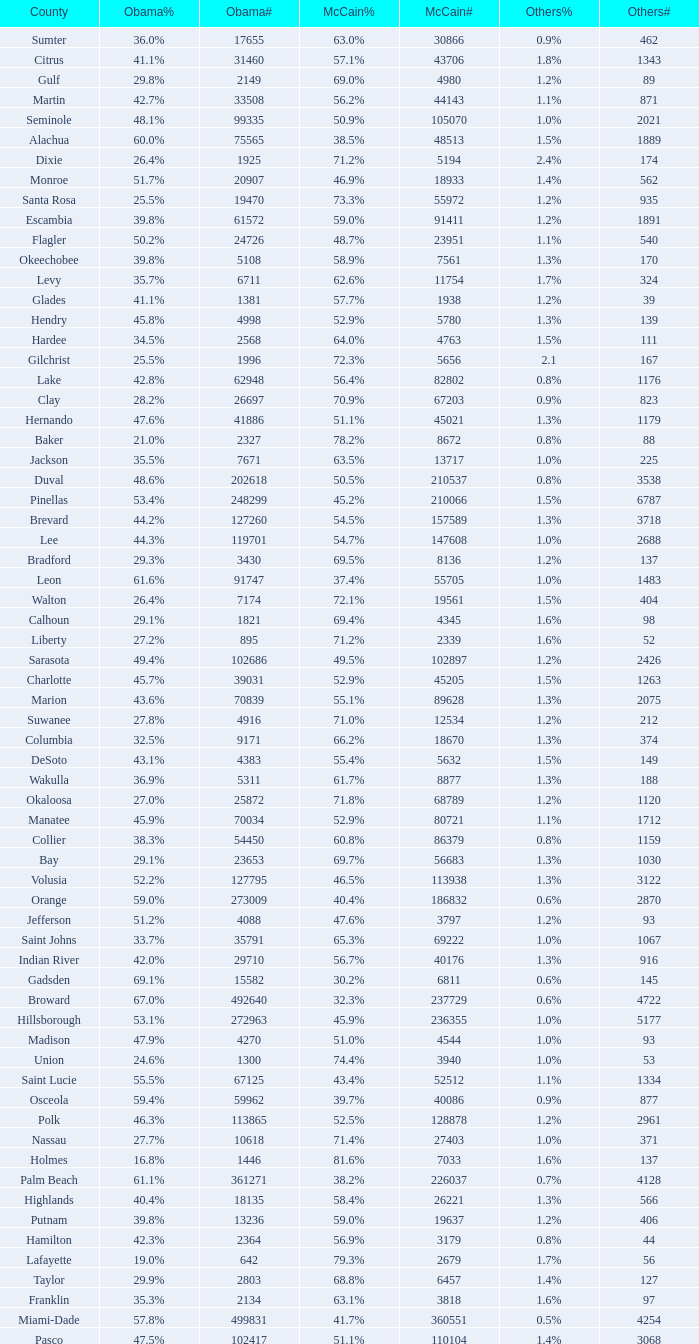What percentage was the others vote when McCain had 52.9% and less than 45205.0 voters? 1.3%. Parse the table in full. {'header': ['County', 'Obama%', 'Obama#', 'McCain%', 'McCain#', 'Others%', 'Others#'], 'rows': [['Sumter', '36.0%', '17655', '63.0%', '30866', '0.9%', '462'], ['Citrus', '41.1%', '31460', '57.1%', '43706', '1.8%', '1343'], ['Gulf', '29.8%', '2149', '69.0%', '4980', '1.2%', '89'], ['Martin', '42.7%', '33508', '56.2%', '44143', '1.1%', '871'], ['Seminole', '48.1%', '99335', '50.9%', '105070', '1.0%', '2021'], ['Alachua', '60.0%', '75565', '38.5%', '48513', '1.5%', '1889'], ['Dixie', '26.4%', '1925', '71.2%', '5194', '2.4%', '174'], ['Monroe', '51.7%', '20907', '46.9%', '18933', '1.4%', '562'], ['Santa Rosa', '25.5%', '19470', '73.3%', '55972', '1.2%', '935'], ['Escambia', '39.8%', '61572', '59.0%', '91411', '1.2%', '1891'], ['Flagler', '50.2%', '24726', '48.7%', '23951', '1.1%', '540'], ['Okeechobee', '39.8%', '5108', '58.9%', '7561', '1.3%', '170'], ['Levy', '35.7%', '6711', '62.6%', '11754', '1.7%', '324'], ['Glades', '41.1%', '1381', '57.7%', '1938', '1.2%', '39'], ['Hendry', '45.8%', '4998', '52.9%', '5780', '1.3%', '139'], ['Hardee', '34.5%', '2568', '64.0%', '4763', '1.5%', '111'], ['Gilchrist', '25.5%', '1996', '72.3%', '5656', '2.1', '167'], ['Lake', '42.8%', '62948', '56.4%', '82802', '0.8%', '1176'], ['Clay', '28.2%', '26697', '70.9%', '67203', '0.9%', '823'], ['Hernando', '47.6%', '41886', '51.1%', '45021', '1.3%', '1179'], ['Baker', '21.0%', '2327', '78.2%', '8672', '0.8%', '88'], ['Jackson', '35.5%', '7671', '63.5%', '13717', '1.0%', '225'], ['Duval', '48.6%', '202618', '50.5%', '210537', '0.8%', '3538'], ['Pinellas', '53.4%', '248299', '45.2%', '210066', '1.5%', '6787'], ['Brevard', '44.2%', '127260', '54.5%', '157589', '1.3%', '3718'], ['Lee', '44.3%', '119701', '54.7%', '147608', '1.0%', '2688'], ['Bradford', '29.3%', '3430', '69.5%', '8136', '1.2%', '137'], ['Leon', '61.6%', '91747', '37.4%', '55705', '1.0%', '1483'], ['Walton', '26.4%', '7174', '72.1%', '19561', '1.5%', '404'], ['Calhoun', '29.1%', '1821', '69.4%', '4345', '1.6%', '98'], ['Liberty', '27.2%', '895', '71.2%', '2339', '1.6%', '52'], ['Sarasota', '49.4%', '102686', '49.5%', '102897', '1.2%', '2426'], ['Charlotte', '45.7%', '39031', '52.9%', '45205', '1.5%', '1263'], ['Marion', '43.6%', '70839', '55.1%', '89628', '1.3%', '2075'], ['Suwanee', '27.8%', '4916', '71.0%', '12534', '1.2%', '212'], ['Columbia', '32.5%', '9171', '66.2%', '18670', '1.3%', '374'], ['DeSoto', '43.1%', '4383', '55.4%', '5632', '1.5%', '149'], ['Wakulla', '36.9%', '5311', '61.7%', '8877', '1.3%', '188'], ['Okaloosa', '27.0%', '25872', '71.8%', '68789', '1.2%', '1120'], ['Manatee', '45.9%', '70034', '52.9%', '80721', '1.1%', '1712'], ['Collier', '38.3%', '54450', '60.8%', '86379', '0.8%', '1159'], ['Bay', '29.1%', '23653', '69.7%', '56683', '1.3%', '1030'], ['Volusia', '52.2%', '127795', '46.5%', '113938', '1.3%', '3122'], ['Orange', '59.0%', '273009', '40.4%', '186832', '0.6%', '2870'], ['Jefferson', '51.2%', '4088', '47.6%', '3797', '1.2%', '93'], ['Saint Johns', '33.7%', '35791', '65.3%', '69222', '1.0%', '1067'], ['Indian River', '42.0%', '29710', '56.7%', '40176', '1.3%', '916'], ['Gadsden', '69.1%', '15582', '30.2%', '6811', '0.6%', '145'], ['Broward', '67.0%', '492640', '32.3%', '237729', '0.6%', '4722'], ['Hillsborough', '53.1%', '272963', '45.9%', '236355', '1.0%', '5177'], ['Madison', '47.9%', '4270', '51.0%', '4544', '1.0%', '93'], ['Union', '24.6%', '1300', '74.4%', '3940', '1.0%', '53'], ['Saint Lucie', '55.5%', '67125', '43.4%', '52512', '1.1%', '1334'], ['Osceola', '59.4%', '59962', '39.7%', '40086', '0.9%', '877'], ['Polk', '46.3%', '113865', '52.5%', '128878', '1.2%', '2961'], ['Nassau', '27.7%', '10618', '71.4%', '27403', '1.0%', '371'], ['Holmes', '16.8%', '1446', '81.6%', '7033', '1.6%', '137'], ['Palm Beach', '61.1%', '361271', '38.2%', '226037', '0.7%', '4128'], ['Highlands', '40.4%', '18135', '58.4%', '26221', '1.3%', '566'], ['Putnam', '39.8%', '13236', '59.0%', '19637', '1.2%', '406'], ['Hamilton', '42.3%', '2364', '56.9%', '3179', '0.8%', '44'], ['Lafayette', '19.0%', '642', '79.3%', '2679', '1.7%', '56'], ['Taylor', '29.9%', '2803', '68.8%', '6457', '1.4%', '127'], ['Franklin', '35.3%', '2134', '63.1%', '3818', '1.6%', '97'], ['Miami-Dade', '57.8%', '499831', '41.7%', '360551', '0.5%', '4254'], ['Pasco', '47.5%', '102417', '51.1%', '110104', '1.4%', '3068']]} 